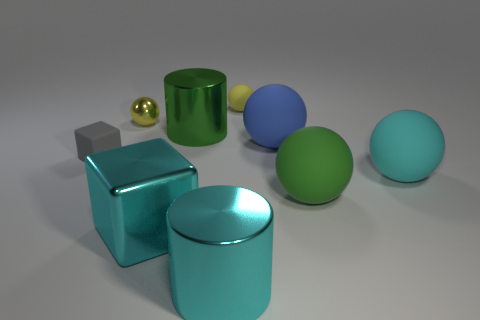How many objects in total are depicted in the image? The image features a total of seven objects, including different geometric shapes like spheres, cubes, and cylinders. 